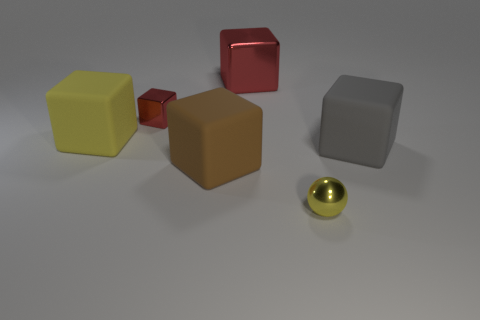Subtract all brown blocks. How many blocks are left? 4 Subtract all blue cylinders. How many red cubes are left? 2 Subtract 2 cubes. How many cubes are left? 3 Subtract all red cubes. How many cubes are left? 3 Add 2 brown matte spheres. How many objects exist? 8 Subtract all spheres. How many objects are left? 5 Subtract all green blocks. Subtract all blue spheres. How many blocks are left? 5 Subtract all large blue metal cubes. Subtract all small metallic objects. How many objects are left? 4 Add 6 tiny red metallic cubes. How many tiny red metallic cubes are left? 7 Add 3 large red metallic spheres. How many large red metallic spheres exist? 3 